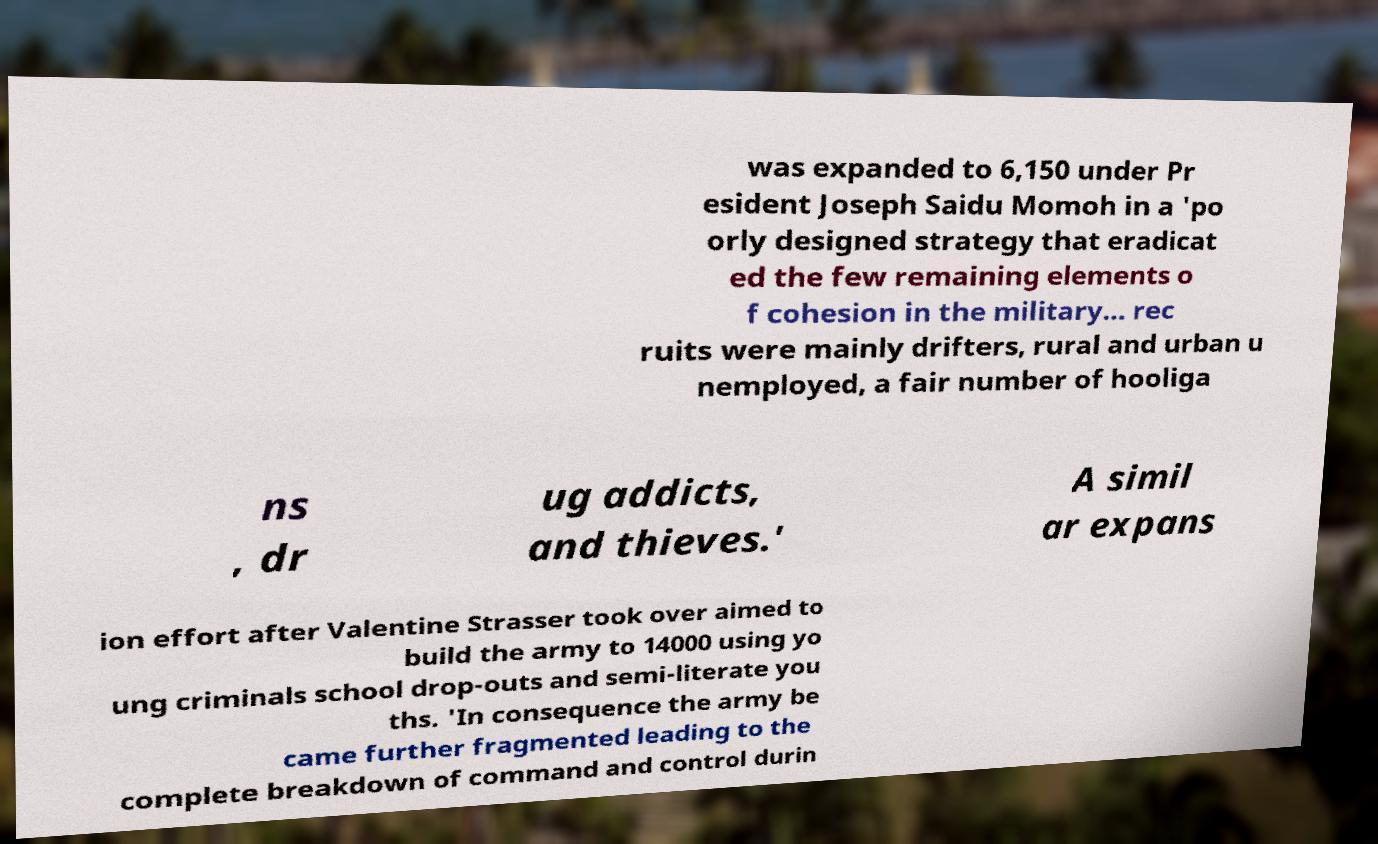I need the written content from this picture converted into text. Can you do that? was expanded to 6,150 under Pr esident Joseph Saidu Momoh in a 'po orly designed strategy that eradicat ed the few remaining elements o f cohesion in the military... rec ruits were mainly drifters, rural and urban u nemployed, a fair number of hooliga ns , dr ug addicts, and thieves.' A simil ar expans ion effort after Valentine Strasser took over aimed to build the army to 14000 using yo ung criminals school drop-outs and semi-literate you ths. 'In consequence the army be came further fragmented leading to the complete breakdown of command and control durin 